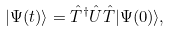<formula> <loc_0><loc_0><loc_500><loc_500>| \Psi ( t ) \rangle = \hat { T } ^ { \dagger } \hat { U } \hat { T } | \Psi ( 0 ) \rangle ,</formula> 